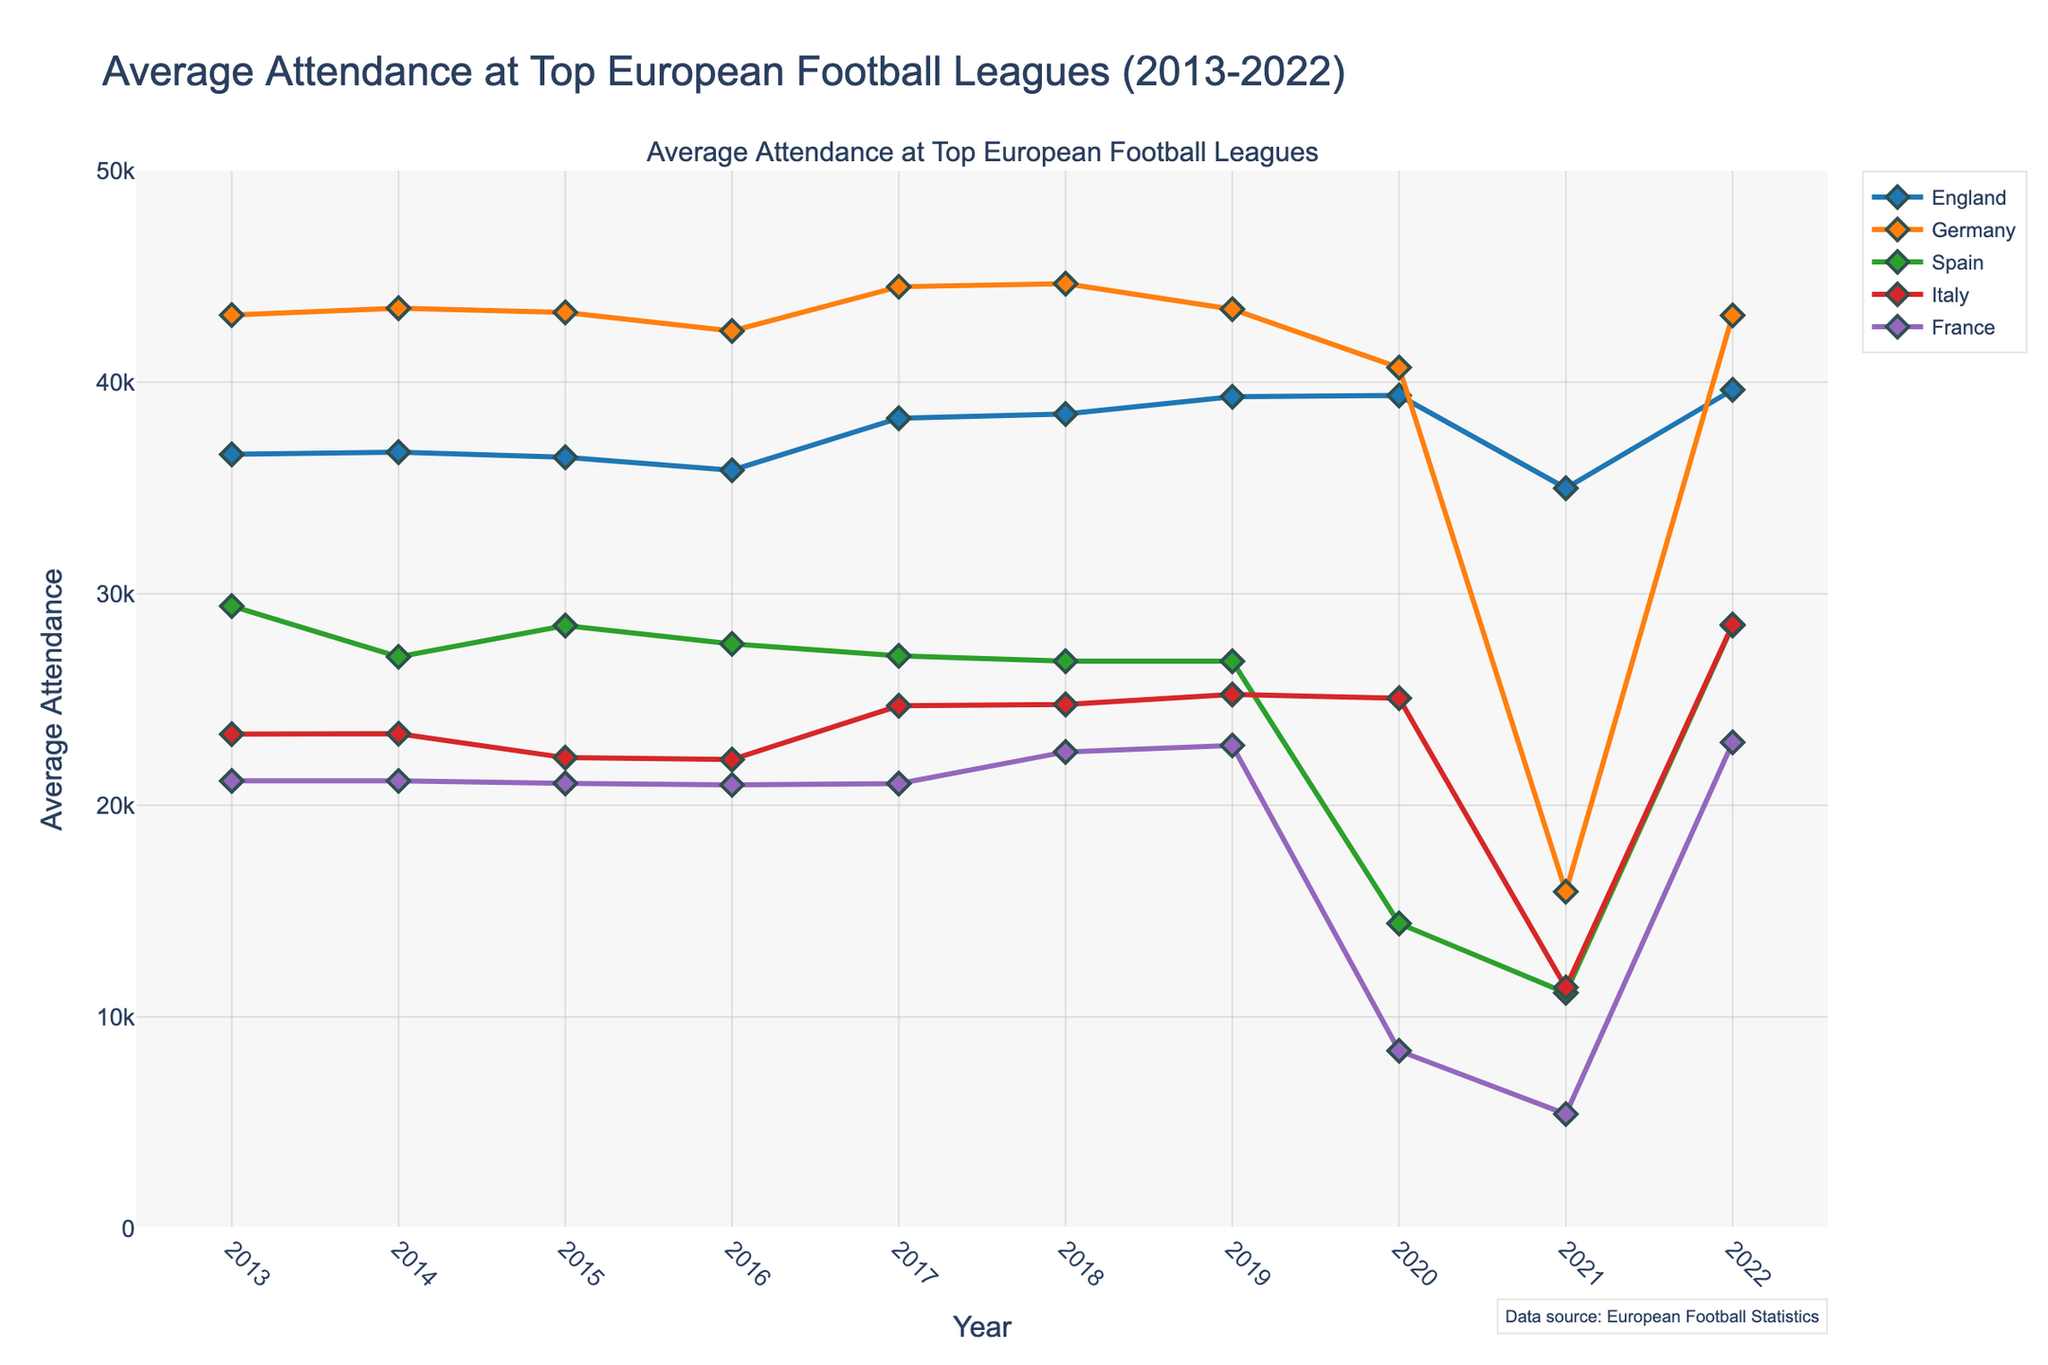Which country had the highest average attendance in 2022? Look at the endpoints of each line for the year 2022. Germany's line reaches the highest point, indicating the highest attendance.
Answer: Germany Which year did France have the lowest average attendance? Observe the plot points for France and find the year when the point is at its lowest. In 2021, France has its lowest average attendance.
Answer: 2021 What was the difference in average attendance between England and Italy in 2017? Locate the points for England and Italy in 2017. England's attendance is approximately 38,297 while Italy's is approximately 24,706. Subtract the two values: 38,297 - 24,706.
Answer: 13,591 In which year did Spain see the greatest drop in average attendance compared to the previous year? Calculate the differences in attendance for Spain year over year. The greatest drop appears between 2019 and 2020 (26,811 to 14,418).
Answer: 2020 By how much did Germany's average attendance change from 2013 to 2022? Compare Germany's attendance in 2013 (43,173) and 2022 (43,158). Subtract the two values: 43,173 - 43,158.
Answer: 15 Which two countries had nearly equal average attendance in 2015? Find and compare the points for all countries in 2015. Spain (28,498) and Germany (43,300) are far different, but when comparing Italy (22,254) and France (21,038), their values are relatively close to each other.
Answer: Italy and France Was there any year when England had higher average attendance than Germany between 2013 and 2022? Examine the plot lines for England and Germany. At no point does England's line cross above Germany's, indicating that Germany always had higher attendance.
Answer: No In 2020, how many countries had an average attendance below 20,000? Identify the points in 2020 and count those below the 20,000 mark: Spain (14,418) and France (8,400).
Answer: Two What is the average attendance for Germany over the entire decade? Add up Germany's average attendance values for all years and divide by the number of years (10): (43,173 + 43,500 + 43,300 + 42,421 + 44,511 + 44,657 + 43,449 + 40,693 + 15,921 + 43,158) / 10.
Answer: 39,078.3 What is the average attendance during the year with the highest overall attendance for each country combined? Sum the attendance values for each country for each year and identify the year with the highest combined value. 2019 has the highest combined attendance.
Answer: 2019 